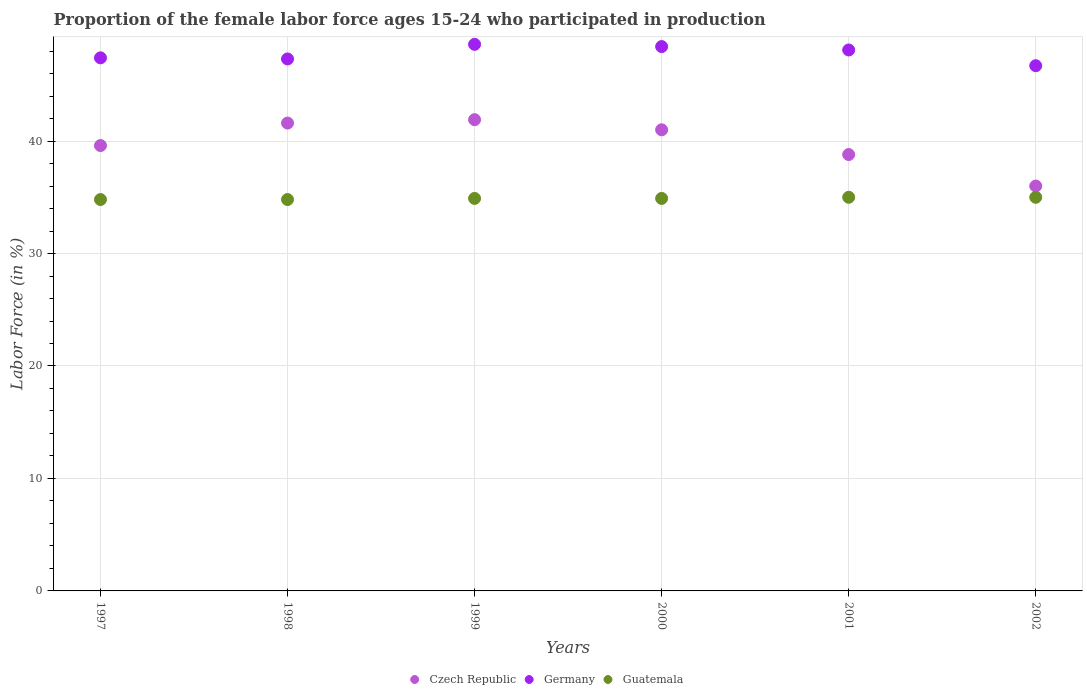How many different coloured dotlines are there?
Your answer should be very brief. 3. What is the proportion of the female labor force who participated in production in Czech Republic in 2002?
Provide a succinct answer. 36. Across all years, what is the minimum proportion of the female labor force who participated in production in Guatemala?
Give a very brief answer. 34.8. In which year was the proportion of the female labor force who participated in production in Guatemala maximum?
Your response must be concise. 2001. What is the total proportion of the female labor force who participated in production in Germany in the graph?
Keep it short and to the point. 286.5. What is the difference between the proportion of the female labor force who participated in production in Germany in 1998 and that in 2000?
Give a very brief answer. -1.1. What is the average proportion of the female labor force who participated in production in Czech Republic per year?
Keep it short and to the point. 39.82. In the year 2001, what is the difference between the proportion of the female labor force who participated in production in Germany and proportion of the female labor force who participated in production in Guatemala?
Ensure brevity in your answer.  13.1. In how many years, is the proportion of the female labor force who participated in production in Czech Republic greater than 16 %?
Your answer should be compact. 6. What is the ratio of the proportion of the female labor force who participated in production in Guatemala in 1999 to that in 2000?
Offer a very short reply. 1. Is the proportion of the female labor force who participated in production in Guatemala in 2000 less than that in 2002?
Provide a succinct answer. Yes. Is the difference between the proportion of the female labor force who participated in production in Germany in 1998 and 1999 greater than the difference between the proportion of the female labor force who participated in production in Guatemala in 1998 and 1999?
Offer a very short reply. No. What is the difference between the highest and the second highest proportion of the female labor force who participated in production in Czech Republic?
Make the answer very short. 0.3. What is the difference between the highest and the lowest proportion of the female labor force who participated in production in Germany?
Provide a short and direct response. 1.9. Is the sum of the proportion of the female labor force who participated in production in Guatemala in 1998 and 1999 greater than the maximum proportion of the female labor force who participated in production in Czech Republic across all years?
Make the answer very short. Yes. Does the proportion of the female labor force who participated in production in Germany monotonically increase over the years?
Make the answer very short. No. How many dotlines are there?
Offer a terse response. 3. Does the graph contain grids?
Ensure brevity in your answer.  Yes. How are the legend labels stacked?
Offer a terse response. Horizontal. What is the title of the graph?
Offer a very short reply. Proportion of the female labor force ages 15-24 who participated in production. What is the label or title of the X-axis?
Give a very brief answer. Years. What is the Labor Force (in %) in Czech Republic in 1997?
Give a very brief answer. 39.6. What is the Labor Force (in %) of Germany in 1997?
Provide a succinct answer. 47.4. What is the Labor Force (in %) in Guatemala in 1997?
Offer a terse response. 34.8. What is the Labor Force (in %) in Czech Republic in 1998?
Offer a terse response. 41.6. What is the Labor Force (in %) in Germany in 1998?
Provide a short and direct response. 47.3. What is the Labor Force (in %) of Guatemala in 1998?
Make the answer very short. 34.8. What is the Labor Force (in %) of Czech Republic in 1999?
Provide a succinct answer. 41.9. What is the Labor Force (in %) of Germany in 1999?
Offer a very short reply. 48.6. What is the Labor Force (in %) of Guatemala in 1999?
Your response must be concise. 34.9. What is the Labor Force (in %) of Czech Republic in 2000?
Ensure brevity in your answer.  41. What is the Labor Force (in %) of Germany in 2000?
Ensure brevity in your answer.  48.4. What is the Labor Force (in %) of Guatemala in 2000?
Make the answer very short. 34.9. What is the Labor Force (in %) of Czech Republic in 2001?
Provide a short and direct response. 38.8. What is the Labor Force (in %) of Germany in 2001?
Offer a terse response. 48.1. What is the Labor Force (in %) of Germany in 2002?
Keep it short and to the point. 46.7. What is the Labor Force (in %) of Guatemala in 2002?
Your response must be concise. 35. Across all years, what is the maximum Labor Force (in %) of Czech Republic?
Provide a succinct answer. 41.9. Across all years, what is the maximum Labor Force (in %) of Germany?
Your answer should be very brief. 48.6. Across all years, what is the maximum Labor Force (in %) of Guatemala?
Ensure brevity in your answer.  35. Across all years, what is the minimum Labor Force (in %) in Germany?
Your answer should be compact. 46.7. Across all years, what is the minimum Labor Force (in %) in Guatemala?
Offer a very short reply. 34.8. What is the total Labor Force (in %) in Czech Republic in the graph?
Make the answer very short. 238.9. What is the total Labor Force (in %) in Germany in the graph?
Give a very brief answer. 286.5. What is the total Labor Force (in %) of Guatemala in the graph?
Provide a succinct answer. 209.4. What is the difference between the Labor Force (in %) of Guatemala in 1997 and that in 1998?
Offer a terse response. 0. What is the difference between the Labor Force (in %) of Czech Republic in 1997 and that in 1999?
Provide a short and direct response. -2.3. What is the difference between the Labor Force (in %) of Czech Republic in 1997 and that in 2000?
Your answer should be compact. -1.4. What is the difference between the Labor Force (in %) in Germany in 1997 and that in 2000?
Offer a very short reply. -1. What is the difference between the Labor Force (in %) of Germany in 1997 and that in 2001?
Offer a terse response. -0.7. What is the difference between the Labor Force (in %) in Guatemala in 1998 and that in 1999?
Keep it short and to the point. -0.1. What is the difference between the Labor Force (in %) in Germany in 1998 and that in 2000?
Your response must be concise. -1.1. What is the difference between the Labor Force (in %) in Germany in 1998 and that in 2001?
Your answer should be compact. -0.8. What is the difference between the Labor Force (in %) in Guatemala in 1998 and that in 2001?
Your answer should be compact. -0.2. What is the difference between the Labor Force (in %) in Czech Republic in 1998 and that in 2002?
Keep it short and to the point. 5.6. What is the difference between the Labor Force (in %) of Germany in 1999 and that in 2000?
Keep it short and to the point. 0.2. What is the difference between the Labor Force (in %) of Guatemala in 1999 and that in 2000?
Your answer should be compact. 0. What is the difference between the Labor Force (in %) of Czech Republic in 1999 and that in 2001?
Offer a very short reply. 3.1. What is the difference between the Labor Force (in %) in Guatemala in 1999 and that in 2001?
Provide a succinct answer. -0.1. What is the difference between the Labor Force (in %) of Germany in 1999 and that in 2002?
Give a very brief answer. 1.9. What is the difference between the Labor Force (in %) of Guatemala in 1999 and that in 2002?
Offer a terse response. -0.1. What is the difference between the Labor Force (in %) of Germany in 2000 and that in 2001?
Offer a very short reply. 0.3. What is the difference between the Labor Force (in %) in Czech Republic in 2000 and that in 2002?
Your response must be concise. 5. What is the difference between the Labor Force (in %) of Germany in 2000 and that in 2002?
Make the answer very short. 1.7. What is the difference between the Labor Force (in %) of Guatemala in 2000 and that in 2002?
Provide a short and direct response. -0.1. What is the difference between the Labor Force (in %) of Guatemala in 2001 and that in 2002?
Your answer should be compact. 0. What is the difference between the Labor Force (in %) of Czech Republic in 1997 and the Labor Force (in %) of Guatemala in 1998?
Make the answer very short. 4.8. What is the difference between the Labor Force (in %) in Czech Republic in 1997 and the Labor Force (in %) in Germany in 1999?
Provide a succinct answer. -9. What is the difference between the Labor Force (in %) in Czech Republic in 1997 and the Labor Force (in %) in Guatemala in 1999?
Keep it short and to the point. 4.7. What is the difference between the Labor Force (in %) of Czech Republic in 1997 and the Labor Force (in %) of Germany in 2000?
Offer a terse response. -8.8. What is the difference between the Labor Force (in %) in Czech Republic in 1997 and the Labor Force (in %) in Guatemala in 2000?
Keep it short and to the point. 4.7. What is the difference between the Labor Force (in %) in Czech Republic in 1997 and the Labor Force (in %) in Germany in 2001?
Your answer should be very brief. -8.5. What is the difference between the Labor Force (in %) in Czech Republic in 1997 and the Labor Force (in %) in Guatemala in 2001?
Your answer should be compact. 4.6. What is the difference between the Labor Force (in %) in Czech Republic in 1997 and the Labor Force (in %) in Germany in 2002?
Provide a succinct answer. -7.1. What is the difference between the Labor Force (in %) in Czech Republic in 1998 and the Labor Force (in %) in Germany in 1999?
Offer a very short reply. -7. What is the difference between the Labor Force (in %) in Czech Republic in 1998 and the Labor Force (in %) in Guatemala in 1999?
Your response must be concise. 6.7. What is the difference between the Labor Force (in %) of Czech Republic in 1998 and the Labor Force (in %) of Germany in 2000?
Your answer should be very brief. -6.8. What is the difference between the Labor Force (in %) in Germany in 1998 and the Labor Force (in %) in Guatemala in 2000?
Offer a very short reply. 12.4. What is the difference between the Labor Force (in %) of Czech Republic in 1998 and the Labor Force (in %) of Guatemala in 2001?
Ensure brevity in your answer.  6.6. What is the difference between the Labor Force (in %) in Germany in 1998 and the Labor Force (in %) in Guatemala in 2002?
Make the answer very short. 12.3. What is the difference between the Labor Force (in %) of Czech Republic in 1999 and the Labor Force (in %) of Germany in 2000?
Your answer should be compact. -6.5. What is the difference between the Labor Force (in %) of Czech Republic in 1999 and the Labor Force (in %) of Guatemala in 2000?
Keep it short and to the point. 7. What is the difference between the Labor Force (in %) of Germany in 1999 and the Labor Force (in %) of Guatemala in 2000?
Provide a short and direct response. 13.7. What is the difference between the Labor Force (in %) in Czech Republic in 1999 and the Labor Force (in %) in Guatemala in 2001?
Your answer should be compact. 6.9. What is the difference between the Labor Force (in %) of Czech Republic in 1999 and the Labor Force (in %) of Germany in 2002?
Make the answer very short. -4.8. What is the difference between the Labor Force (in %) in Czech Republic in 1999 and the Labor Force (in %) in Guatemala in 2002?
Offer a very short reply. 6.9. What is the difference between the Labor Force (in %) in Czech Republic in 2000 and the Labor Force (in %) in Guatemala in 2001?
Keep it short and to the point. 6. What is the difference between the Labor Force (in %) of Czech Republic in 2000 and the Labor Force (in %) of Guatemala in 2002?
Give a very brief answer. 6. What is the difference between the Labor Force (in %) in Czech Republic in 2001 and the Labor Force (in %) in Guatemala in 2002?
Make the answer very short. 3.8. What is the average Labor Force (in %) in Czech Republic per year?
Provide a succinct answer. 39.82. What is the average Labor Force (in %) in Germany per year?
Make the answer very short. 47.75. What is the average Labor Force (in %) of Guatemala per year?
Keep it short and to the point. 34.9. In the year 1997, what is the difference between the Labor Force (in %) in Czech Republic and Labor Force (in %) in Germany?
Your answer should be compact. -7.8. In the year 1998, what is the difference between the Labor Force (in %) in Czech Republic and Labor Force (in %) in Germany?
Ensure brevity in your answer.  -5.7. In the year 1999, what is the difference between the Labor Force (in %) in Czech Republic and Labor Force (in %) in Germany?
Your response must be concise. -6.7. In the year 1999, what is the difference between the Labor Force (in %) of Germany and Labor Force (in %) of Guatemala?
Ensure brevity in your answer.  13.7. In the year 2001, what is the difference between the Labor Force (in %) in Czech Republic and Labor Force (in %) in Germany?
Your response must be concise. -9.3. In the year 2002, what is the difference between the Labor Force (in %) in Czech Republic and Labor Force (in %) in Guatemala?
Your answer should be compact. 1. In the year 2002, what is the difference between the Labor Force (in %) in Germany and Labor Force (in %) in Guatemala?
Your response must be concise. 11.7. What is the ratio of the Labor Force (in %) in Czech Republic in 1997 to that in 1998?
Make the answer very short. 0.95. What is the ratio of the Labor Force (in %) in Guatemala in 1997 to that in 1998?
Provide a short and direct response. 1. What is the ratio of the Labor Force (in %) of Czech Republic in 1997 to that in 1999?
Ensure brevity in your answer.  0.95. What is the ratio of the Labor Force (in %) of Germany in 1997 to that in 1999?
Keep it short and to the point. 0.98. What is the ratio of the Labor Force (in %) of Czech Republic in 1997 to that in 2000?
Give a very brief answer. 0.97. What is the ratio of the Labor Force (in %) in Germany in 1997 to that in 2000?
Your answer should be compact. 0.98. What is the ratio of the Labor Force (in %) of Guatemala in 1997 to that in 2000?
Keep it short and to the point. 1. What is the ratio of the Labor Force (in %) of Czech Republic in 1997 to that in 2001?
Provide a succinct answer. 1.02. What is the ratio of the Labor Force (in %) of Germany in 1997 to that in 2001?
Keep it short and to the point. 0.99. What is the ratio of the Labor Force (in %) in Guatemala in 1997 to that in 2001?
Your answer should be very brief. 0.99. What is the ratio of the Labor Force (in %) of Germany in 1998 to that in 1999?
Offer a terse response. 0.97. What is the ratio of the Labor Force (in %) of Czech Republic in 1998 to that in 2000?
Your answer should be compact. 1.01. What is the ratio of the Labor Force (in %) of Germany in 1998 to that in 2000?
Offer a very short reply. 0.98. What is the ratio of the Labor Force (in %) of Guatemala in 1998 to that in 2000?
Your answer should be compact. 1. What is the ratio of the Labor Force (in %) of Czech Republic in 1998 to that in 2001?
Make the answer very short. 1.07. What is the ratio of the Labor Force (in %) of Germany in 1998 to that in 2001?
Provide a succinct answer. 0.98. What is the ratio of the Labor Force (in %) of Czech Republic in 1998 to that in 2002?
Offer a very short reply. 1.16. What is the ratio of the Labor Force (in %) of Germany in 1998 to that in 2002?
Keep it short and to the point. 1.01. What is the ratio of the Labor Force (in %) of Guatemala in 1998 to that in 2002?
Offer a terse response. 0.99. What is the ratio of the Labor Force (in %) in Czech Republic in 1999 to that in 2001?
Offer a terse response. 1.08. What is the ratio of the Labor Force (in %) in Germany in 1999 to that in 2001?
Ensure brevity in your answer.  1.01. What is the ratio of the Labor Force (in %) of Czech Republic in 1999 to that in 2002?
Your answer should be very brief. 1.16. What is the ratio of the Labor Force (in %) in Germany in 1999 to that in 2002?
Offer a very short reply. 1.04. What is the ratio of the Labor Force (in %) of Czech Republic in 2000 to that in 2001?
Make the answer very short. 1.06. What is the ratio of the Labor Force (in %) in Germany in 2000 to that in 2001?
Your answer should be very brief. 1.01. What is the ratio of the Labor Force (in %) in Czech Republic in 2000 to that in 2002?
Offer a terse response. 1.14. What is the ratio of the Labor Force (in %) of Germany in 2000 to that in 2002?
Provide a short and direct response. 1.04. What is the ratio of the Labor Force (in %) in Guatemala in 2000 to that in 2002?
Provide a short and direct response. 1. What is the ratio of the Labor Force (in %) in Czech Republic in 2001 to that in 2002?
Provide a succinct answer. 1.08. What is the ratio of the Labor Force (in %) of Germany in 2001 to that in 2002?
Your response must be concise. 1.03. What is the ratio of the Labor Force (in %) in Guatemala in 2001 to that in 2002?
Offer a terse response. 1. What is the difference between the highest and the second highest Labor Force (in %) of Czech Republic?
Your response must be concise. 0.3. What is the difference between the highest and the second highest Labor Force (in %) of Guatemala?
Offer a very short reply. 0. What is the difference between the highest and the lowest Labor Force (in %) in Germany?
Provide a short and direct response. 1.9. 